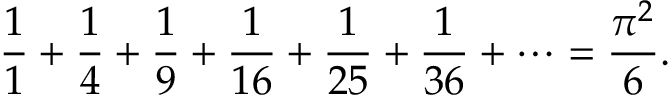<formula> <loc_0><loc_0><loc_500><loc_500>{ \frac { 1 } { 1 } } + { \frac { 1 } { 4 } } + { \frac { 1 } { 9 } } + { \frac { 1 } { 1 6 } } + { \frac { 1 } { 2 5 } } + { \frac { 1 } { 3 6 } } + \cdots = { \frac { \pi ^ { 2 } } { 6 } } .</formula> 